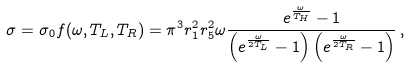Convert formula to latex. <formula><loc_0><loc_0><loc_500><loc_500>\sigma = \sigma _ { 0 } f ( \omega , T _ { L } , T _ { R } ) = \pi ^ { 3 } r _ { 1 } ^ { 2 } r _ { 5 } ^ { 2 } \omega \frac { e ^ { \frac { \omega } { T _ { H } } } - 1 } { \left ( e ^ { \frac { \omega } { 2 T _ { L } } } - 1 \right ) \left ( e ^ { \frac { \omega } { 2 T _ { R } } } - 1 \right ) } \, ,</formula> 